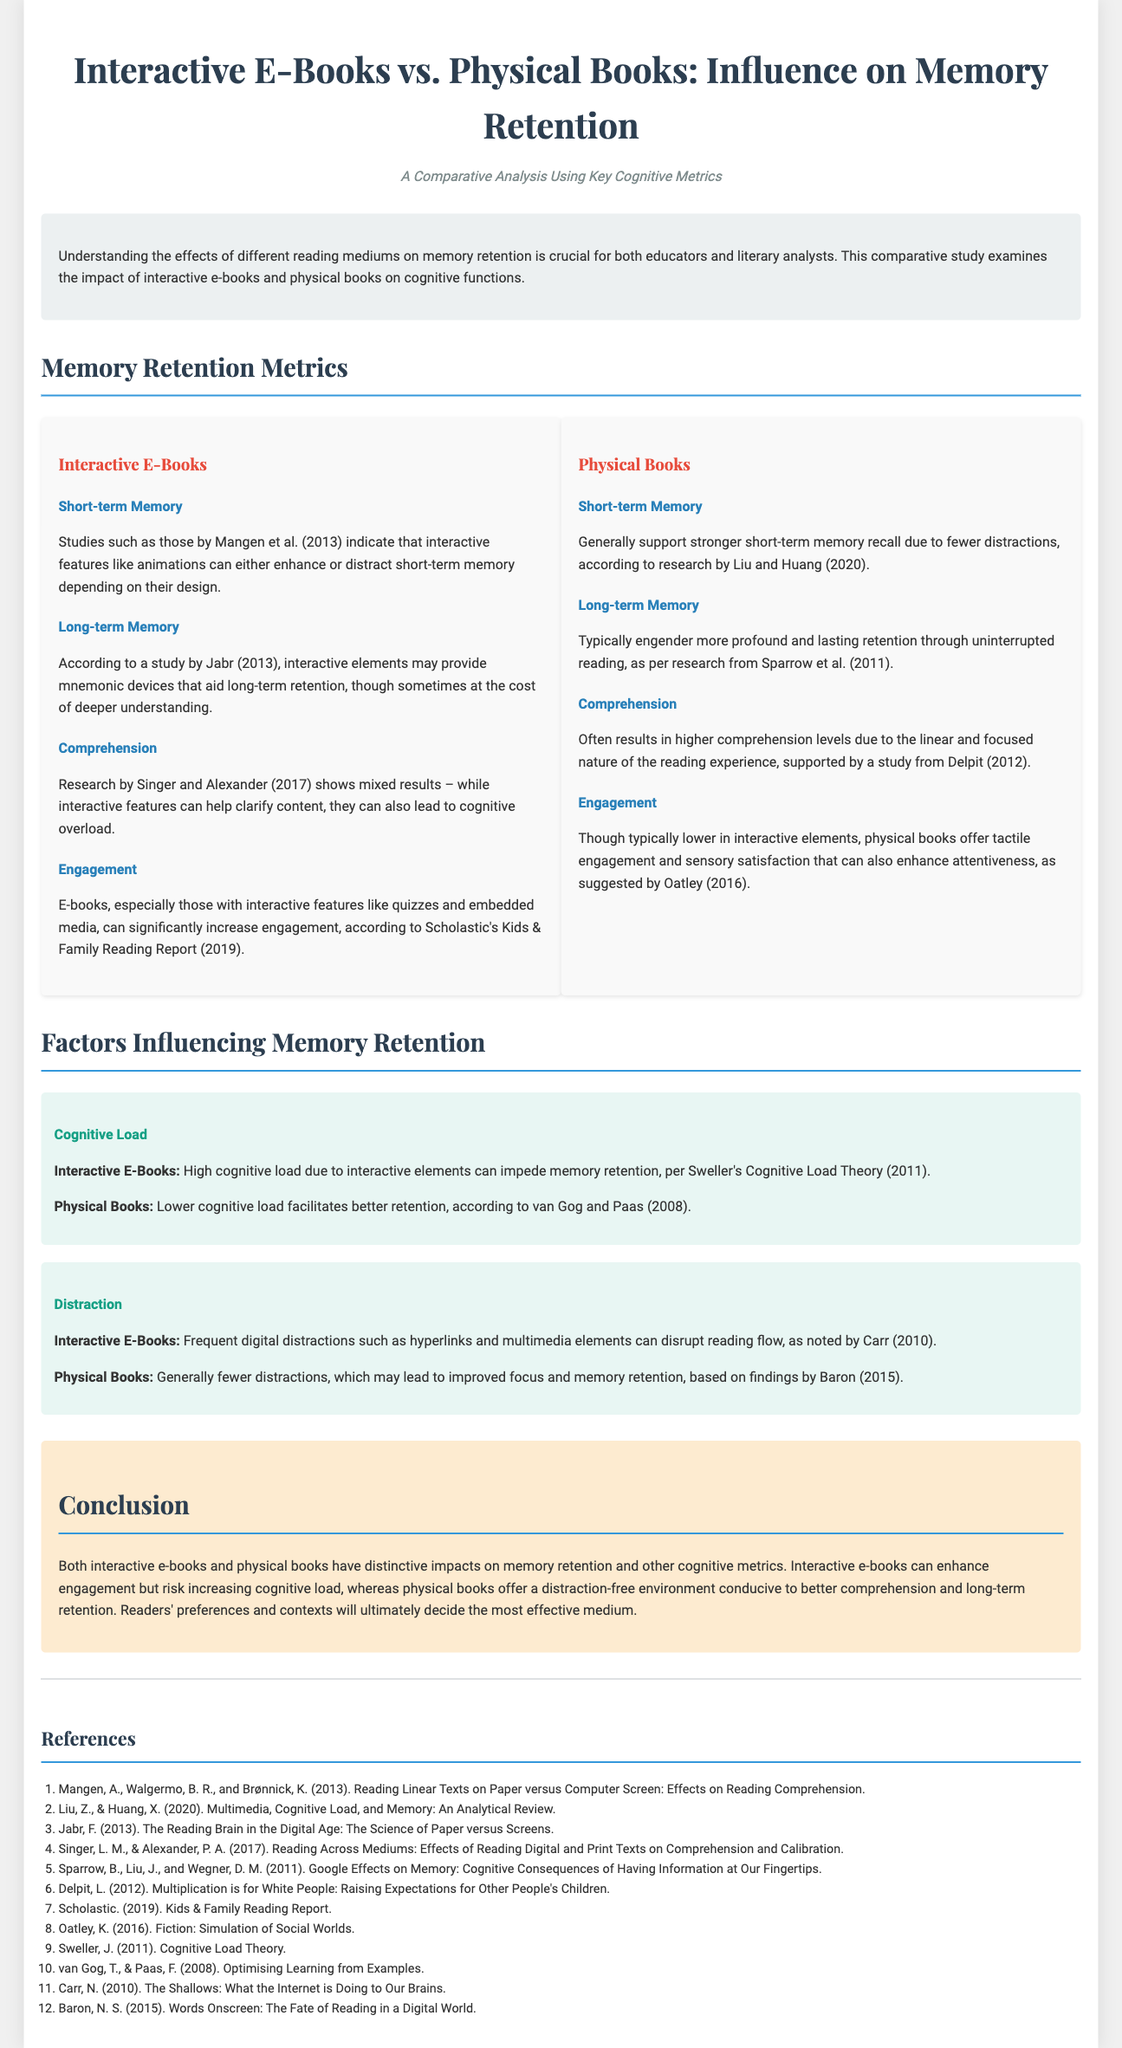what is compared in this infographic? The infographic compares interactive e-books and physical books in terms of their influence on memory retention.
Answer: interactive e-books and physical books who conducted the study regarding short-term memory in interactive e-books? The study on short-term memory in interactive e-books was conducted by Mangen et al.
Answer: Mangen et al which book type generally supports stronger short-term memory recall? According to research by Liu and Huang, physical books support stronger short-term memory recall.
Answer: physical books what is one factor influencing memory retention in interactive e-books? One factor influencing memory retention in interactive e-books is cognitive load, as per Sweller's Cognitive Load Theory.
Answer: cognitive load which cognitive metric shows mixed results for interactive e-books? The cognitive metric that shows mixed results for interactive e-books is comprehension, based on research by Singer and Alexander.
Answer: comprehension what does physical books typically engender according to the document? Physical books typically engender more profound and lasting retention through uninterrupted reading.
Answer: more profound and lasting retention which aspect of e-books can increase engagement? Interactive features like quizzes and embedded media can significantly increase engagement in e-books.
Answer: interactive features who published the Kids & Family Reading Report mentioned in the document? The Kids & Family Reading Report was published by Scholastic.
Answer: Scholastic how does physical books' distraction level compare to e-books? Physical books have generally fewer distractions compared to interactive e-books.
Answer: fewer distractions 